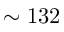Convert formula to latex. <formula><loc_0><loc_0><loc_500><loc_500>\sim 1 3 2</formula> 